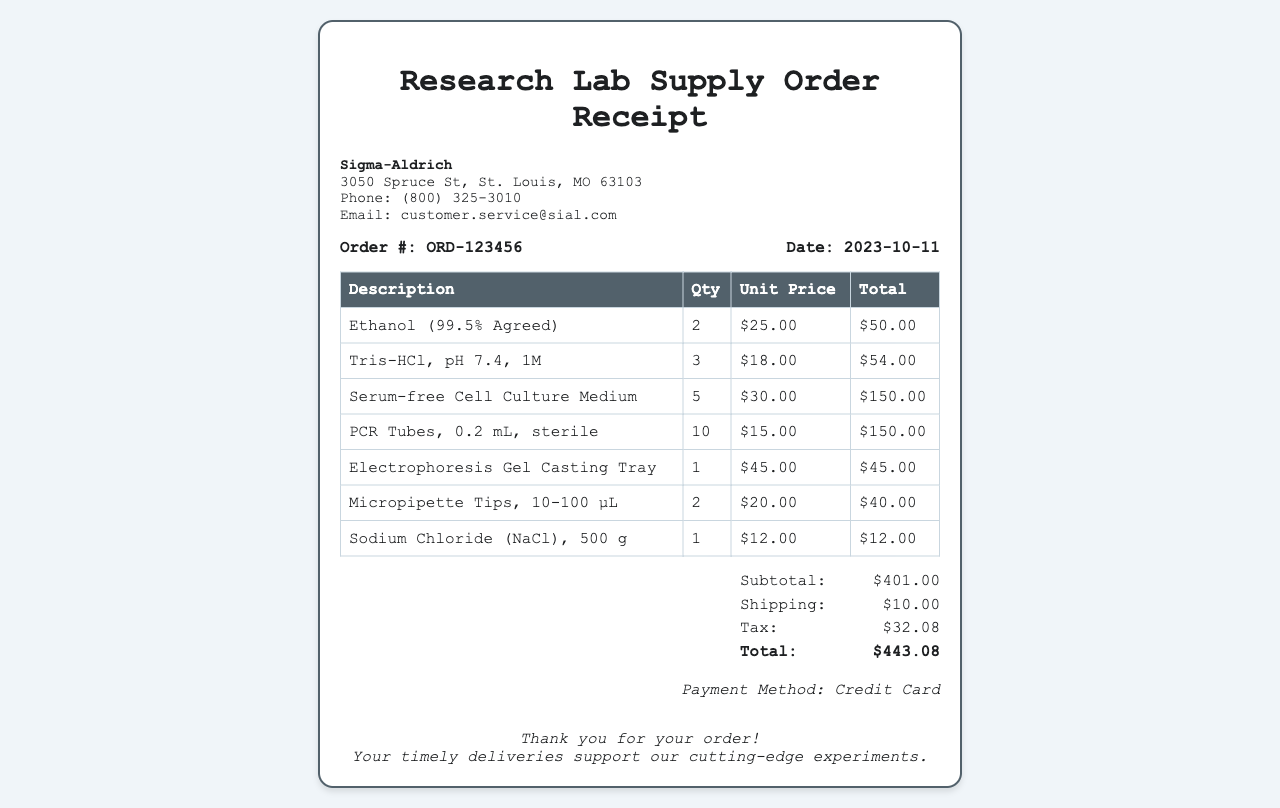What is the order number? The order number is listed in the document under order info, specified as ORD-123456.
Answer: ORD-123456 What is the date of the order? The date of the order is presented in the order info section as 2023-10-11.
Answer: 2023-10-11 Who is the vendor? The vendor is indicated at the top of the receipt as Sigma-Aldrich.
Answer: Sigma-Aldrich What is the total amount billed? The total amount billed is found in the totals section, calculated as $443.08.
Answer: $443.08 How many PCR tubes were ordered? The quantity of PCR tubes is specified in the item section as 10.
Answer: 10 What is the subtotal of the order? The subtotal is detailed in the totals section, appearing as $401.00.
Answer: $401.00 Which item has the highest unit price? The item with the highest unit price is listed as Serum-free Cell Culture Medium, costing $30.00 each.
Answer: Serum-free Cell Culture Medium What payment method was used? The payment method is indicated at the bottom of the document, specified as Credit Card.
Answer: Credit Card What is the shipping charge? The shipping charge is detailed in the totals section as $10.00.
Answer: $10.00 